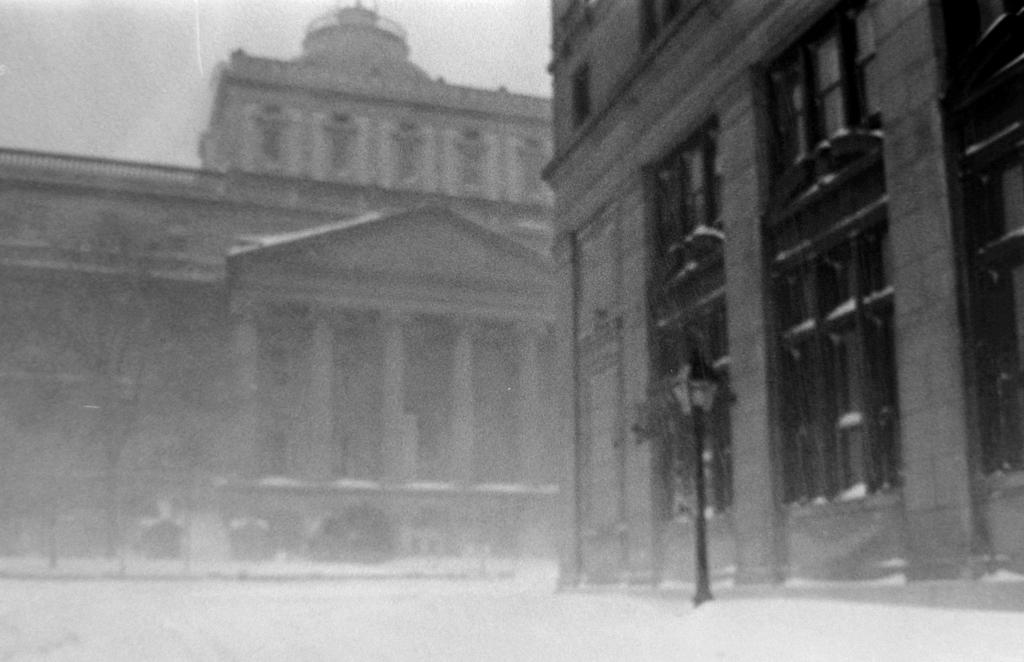How many buildings can be seen in the image? There are two buildings in the image. What can be seen in the background of the image? There is a sky visible in the image. What type of man-made object is present in the image? There is a street lamp in the image. What type of natural element is present in the image? There are trees in the image. What type of sink can be seen in the image? There is no sink present in the image. What type of relation can be seen between the two buildings in the image? The image does not show any specific relation between the two buildings; they are simply side by side. 